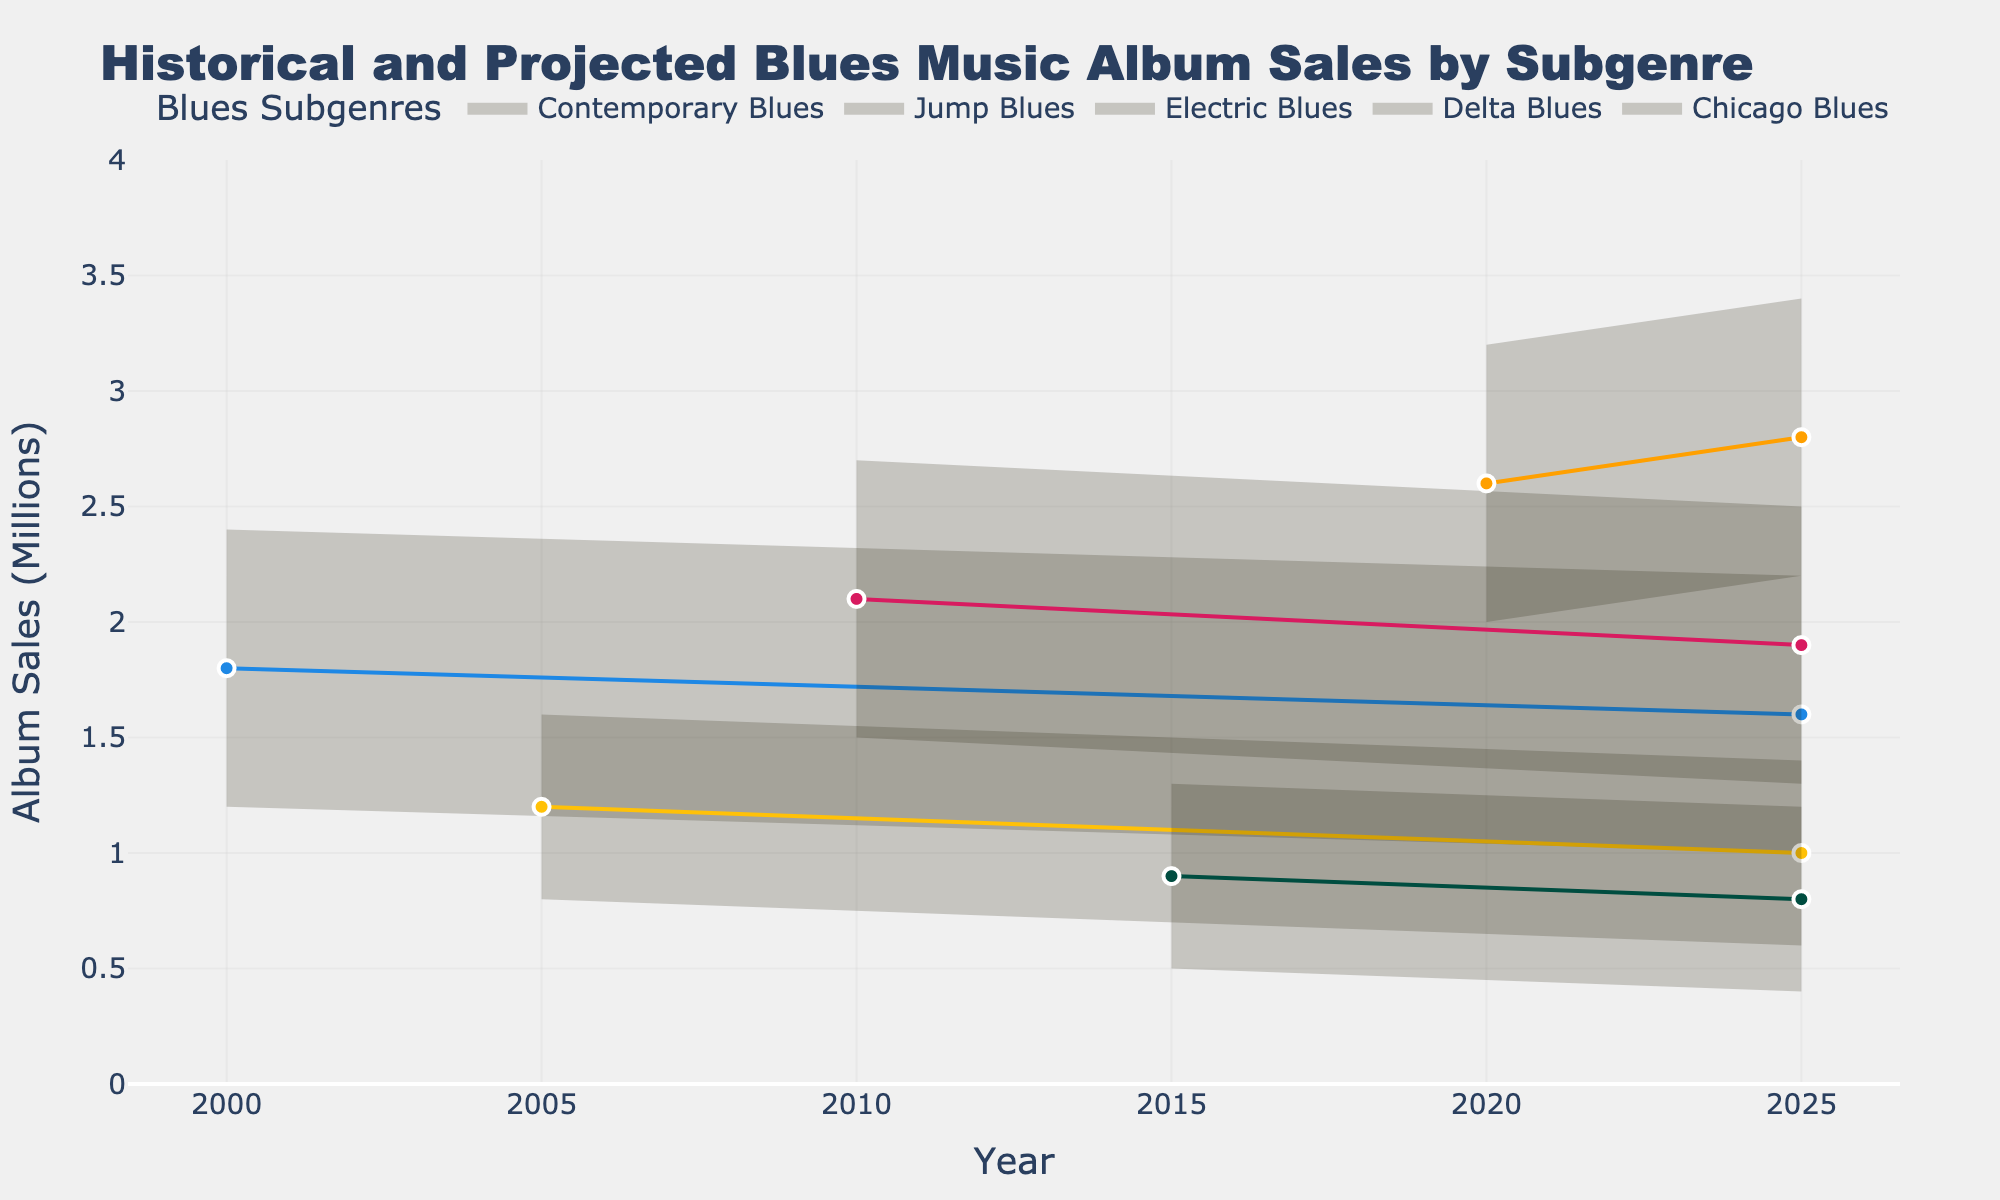What is the title of the figure? The title of the figure is located at the top and centers the visual's text.
Answer: Historical and Projected Blues Music Album Sales by Subgenre What is the X-axis title and its increments? The X-axis (horizontal axis) title is found below the axis, and its increments are the specific labels displayed along the axis.
Answer: Year, increments of 5 years Which subgenre had the highest album sales in 2020? Looking at the 2020 data point, identify which subgenre reaches the highest point vertically. Contemporary Blues has the highest value.
Answer: Contemporary Blues By how much do the projected 'Mid' sales of Chicago Blues in 2025 differ from the 2000 value? Compare the 'Mid' values of Chicago Blues in 2000 and 2025. The value in 2000 is 1.8 million, and the value projected for 2025 is 1.6 million. Subtracting these gives a difference of 0.2 million.
Answer: 0.2 million What is the range of album sales in 2015 for Jump Blues? The range is calculated by finding the difference between 'High' and 'Low' values for Jump Blues in 2015. High is 1.3 million and Low is 0.5 million, so the difference is 1.3 - 0.5 = 0.8 million.
Answer: 0.8 million What is the overall trend of Electric Blues album sales from 2000 to 2025? Assess how the 'Mid' value changes from 2000 to 2025. For Electric Blues in 2010, it is 2.1 million, and despite not having data points in 2000, projected 2025 is 1.9 million, showing a slight decrease.
Answer: Slight decrease How does the 'Mid' projection of Delta Blues in 2025 compare with its value in 2005? Compare the 'Mid' values for Delta Blues in 2005 and the projected value in 2025. The value in 2005 is 1.2 million and the projected value in 2025 is 1.0 million, so 2025 is lower.
Answer: Lower Which subgenre shows the most uncertainty in the projected album sales in 2025? The subgenre with the largest difference between the 'High' and 'Low' values in 2025 shows the most uncertainty. Contemporary Blues has a range from 2.2 to 3.4 million, giving a difference of 1.2 million.
Answer: Contemporary Blues What is the trend for 'Mid' values of Chicago Blues from 2000 to 2025? Track the 'Mid' values for Chicago Blues starting at 1.8 in 2000 and projecting it to 1.6 in 2025. It shows a decreasing trend.
Answer: Decreasing 